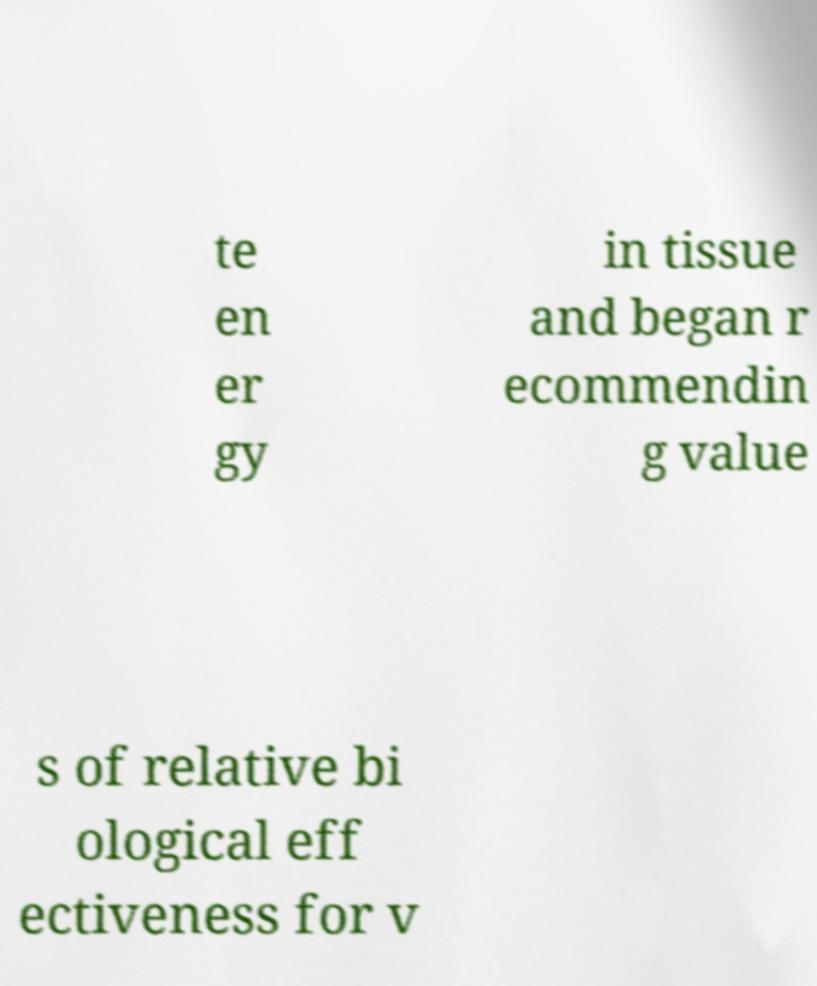Please identify and transcribe the text found in this image. te en er gy in tissue and began r ecommendin g value s of relative bi ological eff ectiveness for v 